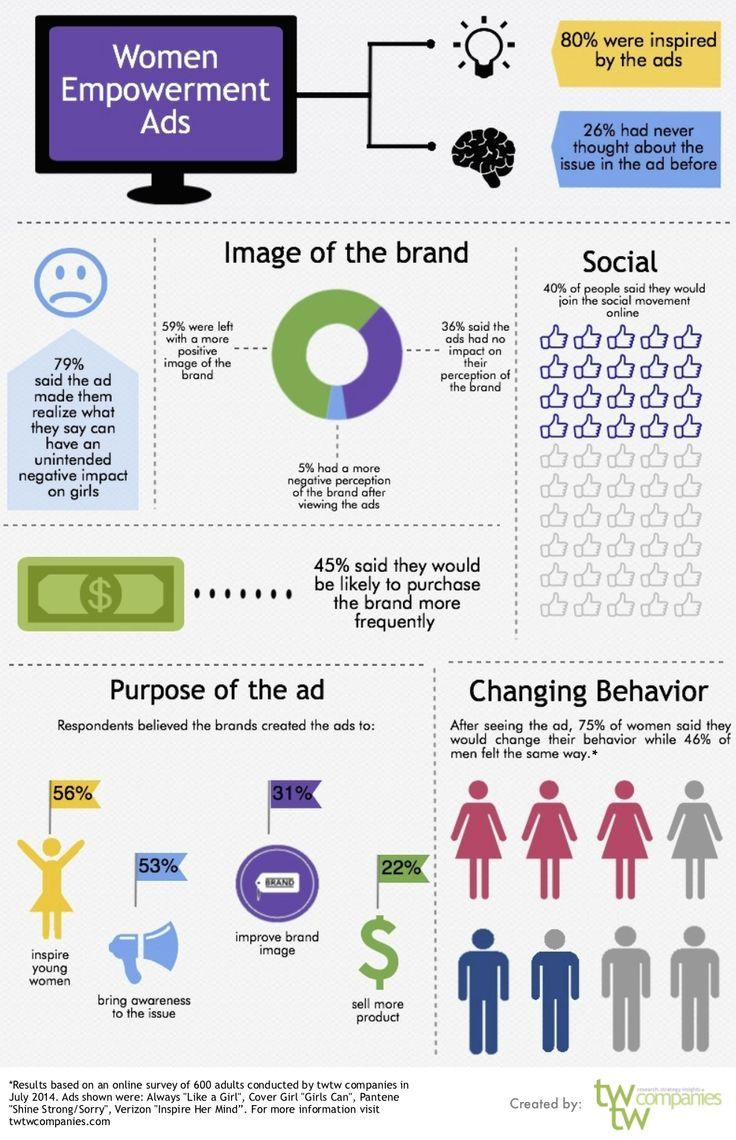Mention a couple of crucial points in this snapshot. According to the survey results, 53% of respondents believed that the purpose of ads is to bring awareness to the issue. According to the respondents, 22% believed that the purpose of ads is to sell more product. A total of 31% of respondents believed that the primary purpose of advertisements is to enhance brand image. A total of 56% of respondents believed that the purpose of ads is to inspire young women. 